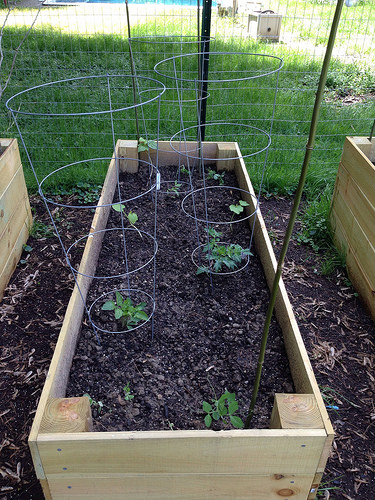<image>
Is there a bamboo stick on the raised bed? No. The bamboo stick is not positioned on the raised bed. They may be near each other, but the bamboo stick is not supported by or resting on top of the raised bed. 